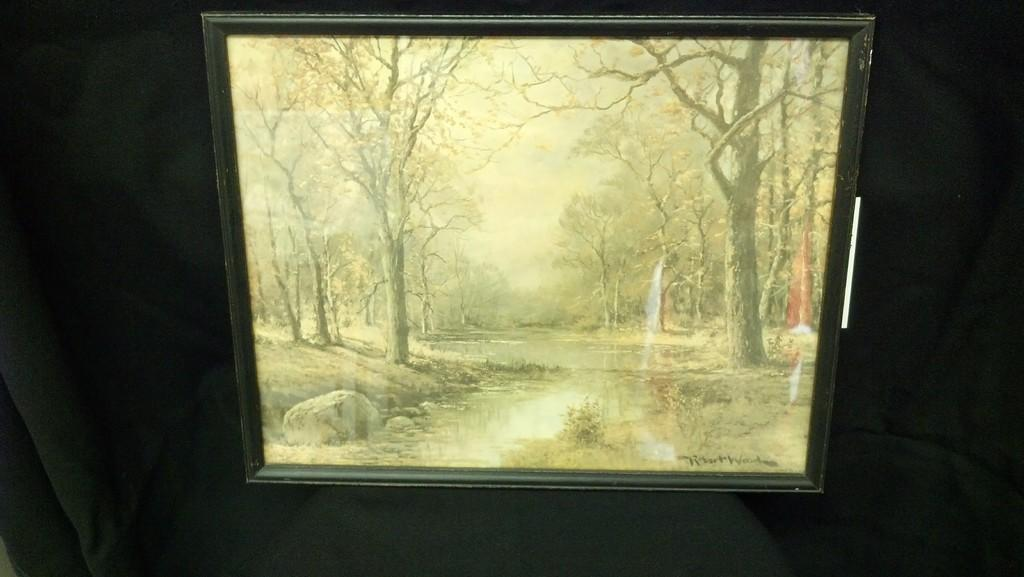What is placed on the black surface in the image? There is a frame on a black surface. What can be seen inside the frame? The frame contains an image with trees, water, rocks, and sky. Can you describe the elements present in the image within the frame? The image within the frame includes trees, water, rocks, and sky. What type of face can be seen in the image? There is no face present in the image; it features a frame with an image containing trees, water, rocks, and sky. Is there a trail visible in the image? There is no trail visible in the image; it only contains an image with trees, water, rocks, and sky within the frame. 